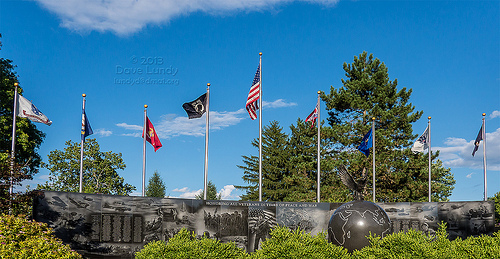<image>
Is the flag in front of the wall? No. The flag is not in front of the wall. The spatial positioning shows a different relationship between these objects. 